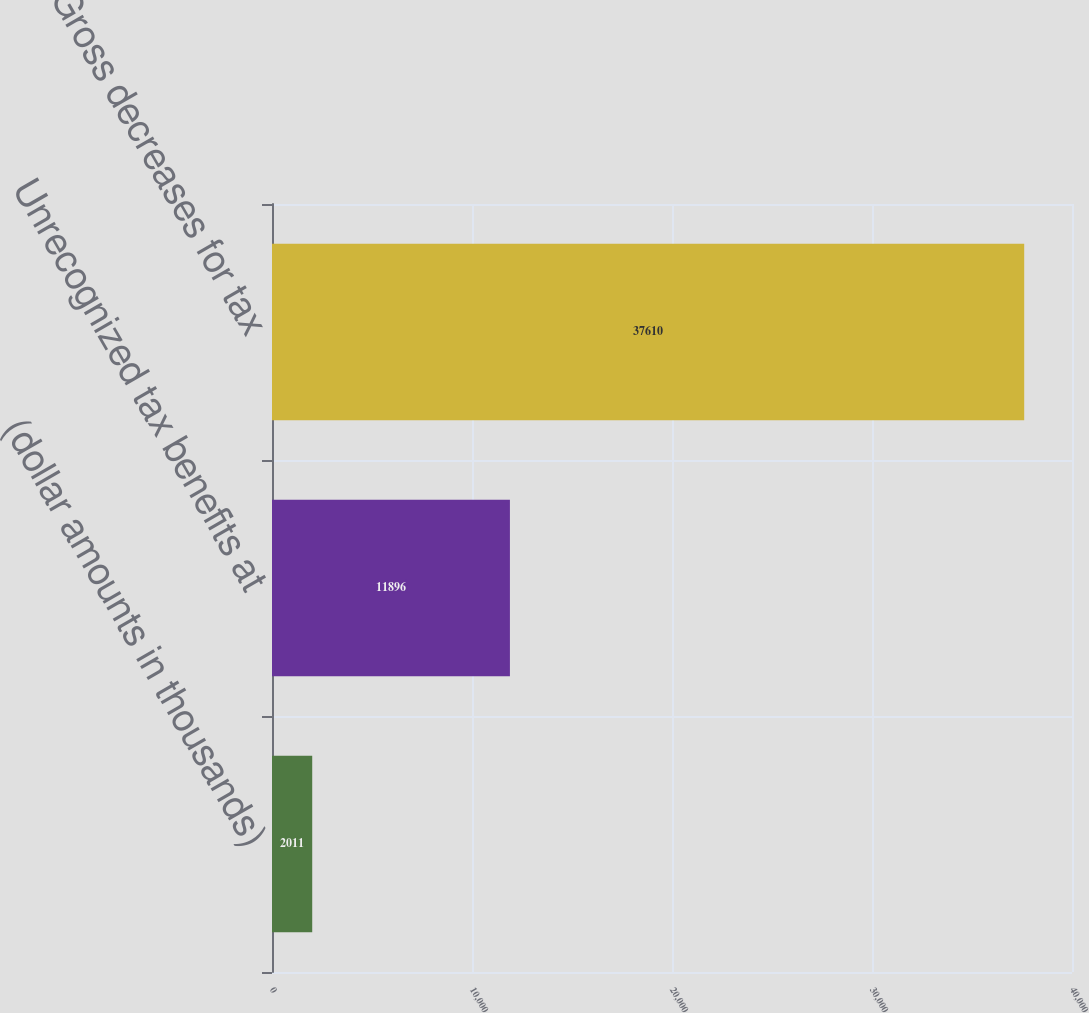Convert chart. <chart><loc_0><loc_0><loc_500><loc_500><bar_chart><fcel>(dollar amounts in thousands)<fcel>Unrecognized tax benefits at<fcel>Gross decreases for tax<nl><fcel>2011<fcel>11896<fcel>37610<nl></chart> 